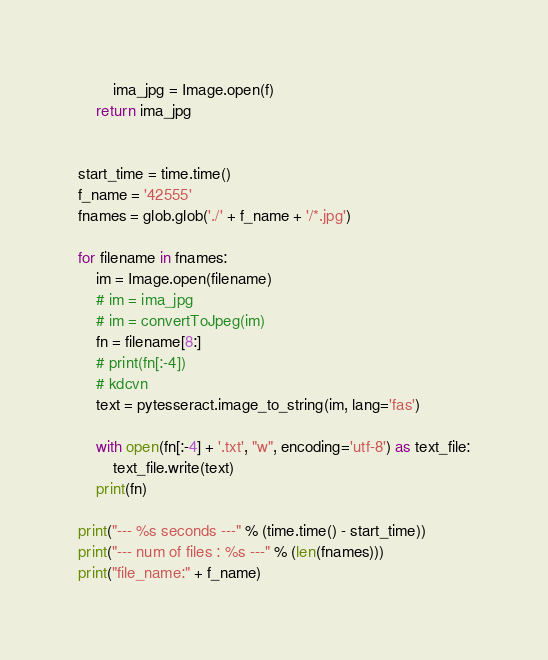Convert code to text. <code><loc_0><loc_0><loc_500><loc_500><_Python_>        ima_jpg = Image.open(f)
    return ima_jpg


start_time = time.time()
f_name = '42555'
fnames = glob.glob('./' + f_name + '/*.jpg')

for filename in fnames:
    im = Image.open(filename)
    # im = ima_jpg
    # im = convertToJpeg(im)
    fn = filename[8:]
    # print(fn[:-4])
    # kdcvn
    text = pytesseract.image_to_string(im, lang='fas')

    with open(fn[:-4] + '.txt', "w", encoding='utf-8') as text_file:
        text_file.write(text)
    print(fn)

print("--- %s seconds ---" % (time.time() - start_time))
print("--- num of files : %s ---" % (len(fnames)))
print("file_name:" + f_name)
</code> 